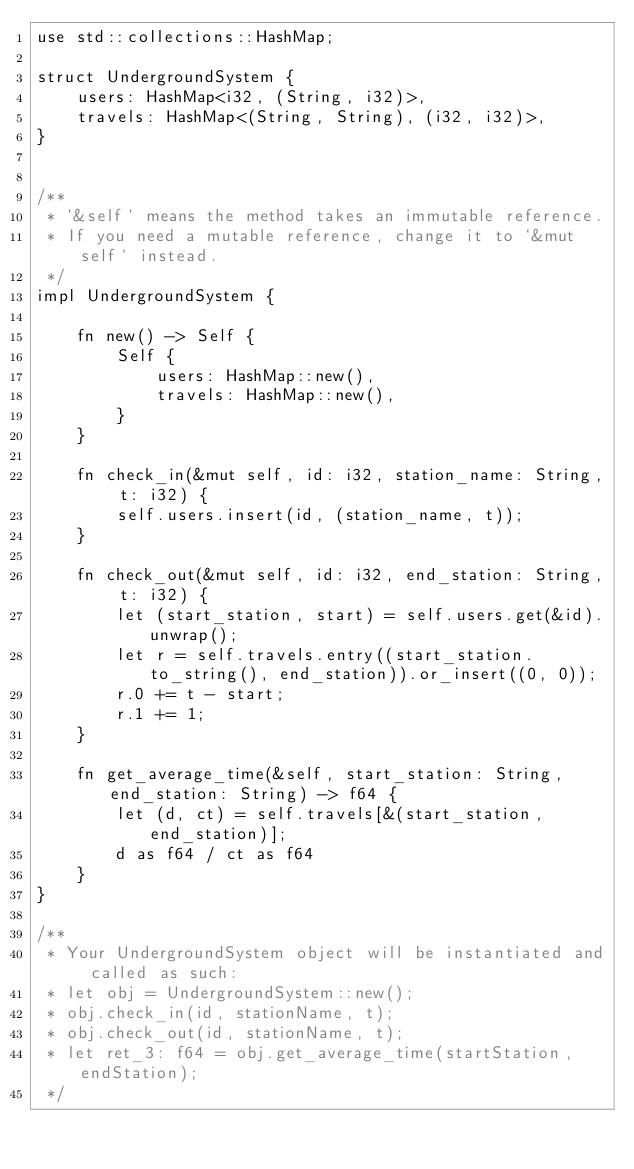Convert code to text. <code><loc_0><loc_0><loc_500><loc_500><_Rust_>use std::collections::HashMap;

struct UndergroundSystem {
    users: HashMap<i32, (String, i32)>,
    travels: HashMap<(String, String), (i32, i32)>,
}


/** 
 * `&self` means the method takes an immutable reference.
 * If you need a mutable reference, change it to `&mut self` instead.
 */
impl UndergroundSystem {

    fn new() -> Self {
        Self {
            users: HashMap::new(),
            travels: HashMap::new(),
        }
    }
    
    fn check_in(&mut self, id: i32, station_name: String, t: i32) {
        self.users.insert(id, (station_name, t));
    }
    
    fn check_out(&mut self, id: i32, end_station: String, t: i32) {
        let (start_station, start) = self.users.get(&id).unwrap();
        let r = self.travels.entry((start_station.to_string(), end_station)).or_insert((0, 0));
        r.0 += t - start;
        r.1 += 1;      
    }
    
    fn get_average_time(&self, start_station: String, end_station: String) -> f64 {
        let (d, ct) = self.travels[&(start_station, end_station)];
        d as f64 / ct as f64
    }
}

/**
 * Your UndergroundSystem object will be instantiated and called as such:
 * let obj = UndergroundSystem::new();
 * obj.check_in(id, stationName, t);
 * obj.check_out(id, stationName, t);
 * let ret_3: f64 = obj.get_average_time(startStation, endStation);
 */
</code> 